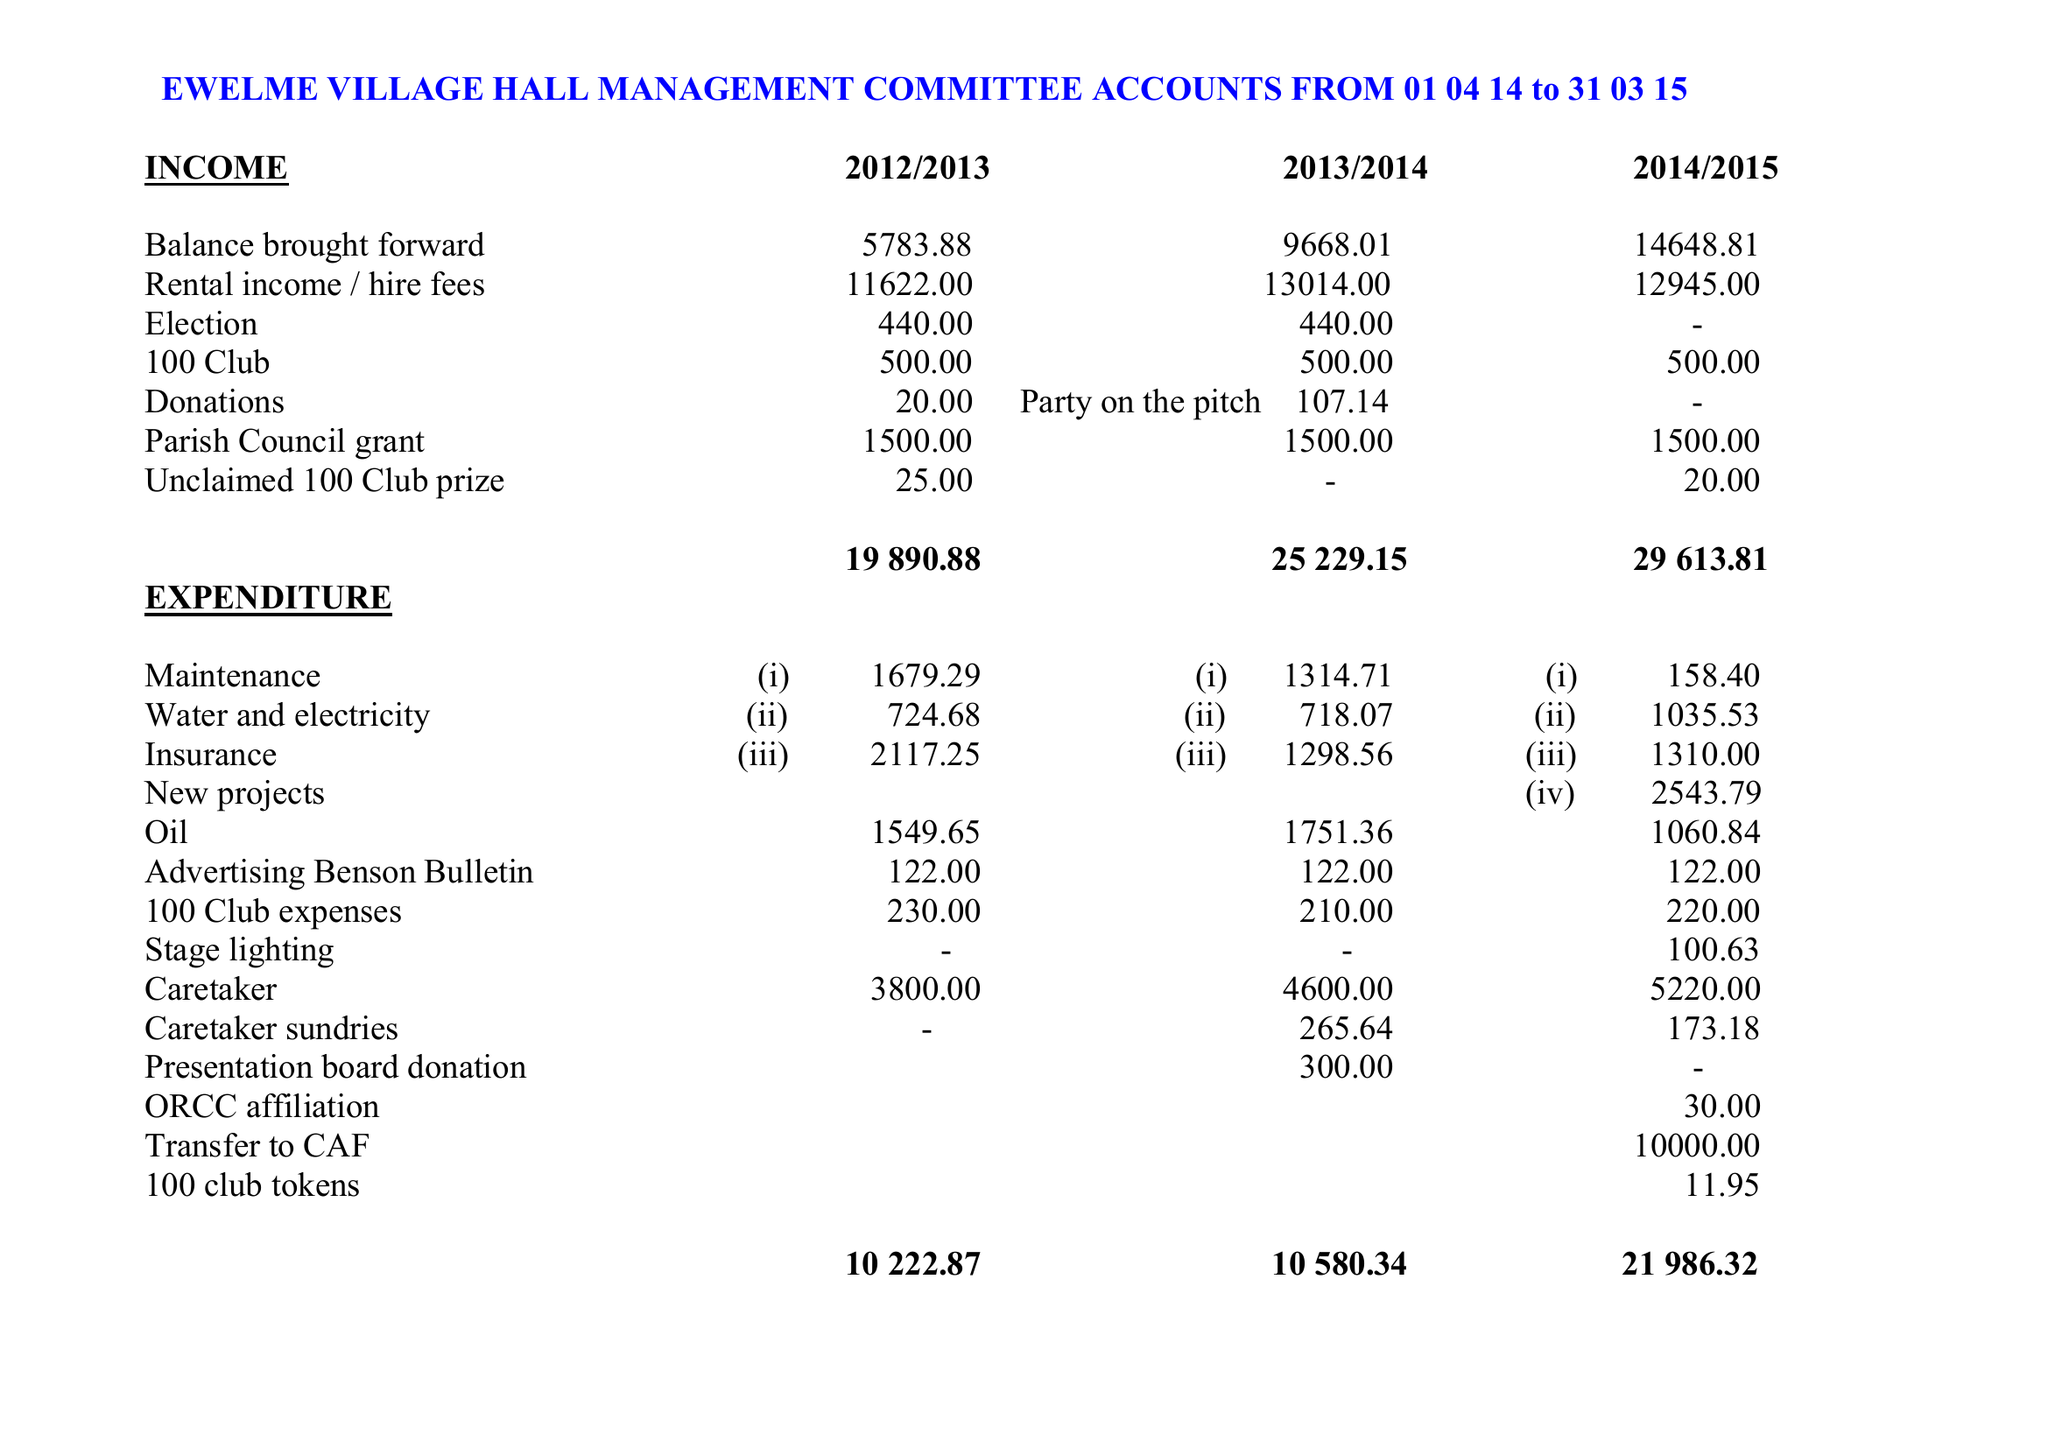What is the value for the address__postcode?
Answer the question using a single word or phrase. OX10 6HW 